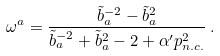<formula> <loc_0><loc_0><loc_500><loc_500>\omega ^ { a } = \frac { \tilde { b } _ { a } ^ { - 2 } - \tilde { b } _ { a } ^ { 2 } } { \tilde { b } _ { a } ^ { - 2 } + \tilde { b } _ { a } ^ { 2 } - 2 + \alpha ^ { \prime } p ^ { 2 } _ { n . c . } } \, .</formula> 